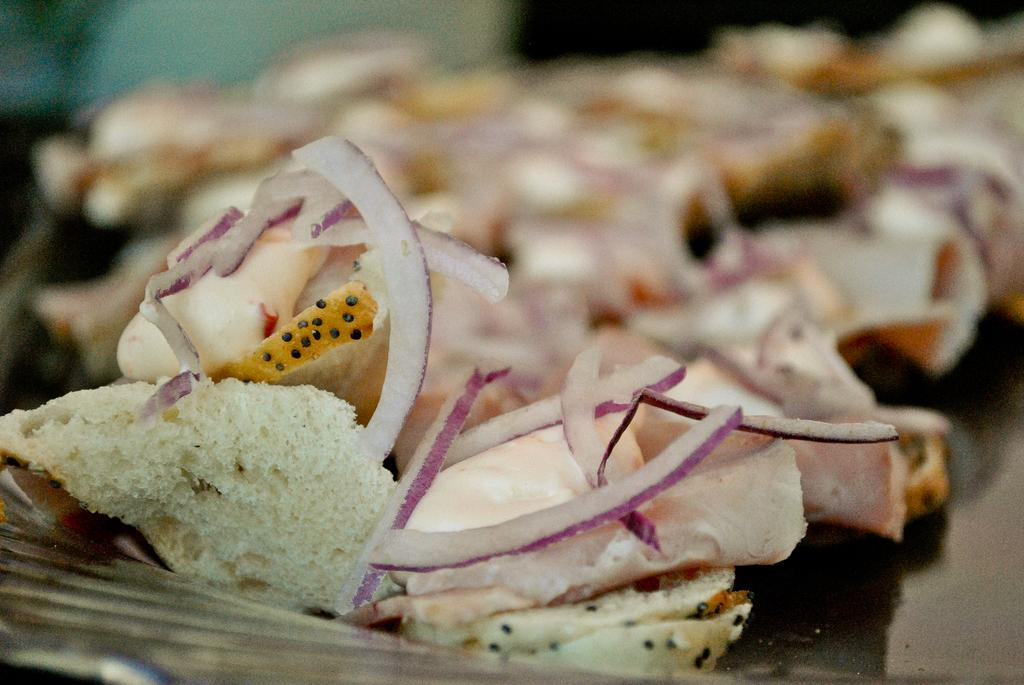What is the main subject of the image? The main subject of the image is food. What can be observed about the surface the food is placed on? The food is on a black surface. What colors are present in the food? The food has white, yellow, and black colors. How would you describe the appearance of the food in the image? The image of the food is blurred. What type of brass instrument is being played in the image? There is no brass instrument present in the image; it features food on a black surface. What type of lumber is used to build the house in the image? There is no house or lumber present in the image; it features food on a black surface. 